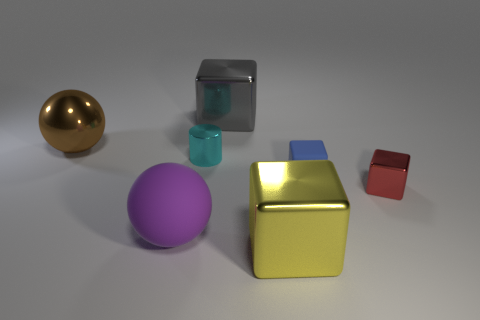Is the tiny blue cube that is right of the yellow cube made of the same material as the cube in front of the large purple rubber object?
Keep it short and to the point. No. There is a tiny thing right of the blue matte thing; what material is it?
Ensure brevity in your answer.  Metal. What number of metallic things are small blue objects or gray blocks?
Your response must be concise. 1. There is a thing that is behind the sphere behind the small red metal thing; what is its color?
Your answer should be very brief. Gray. Is the large brown sphere made of the same material as the large block that is to the right of the big gray metallic cube?
Offer a terse response. Yes. What is the color of the thing that is on the left side of the matte object left of the large thing that is in front of the purple rubber thing?
Make the answer very short. Brown. Is there any other thing that has the same shape as the tiny red thing?
Your answer should be compact. Yes. Are there more tiny red metallic blocks than big brown shiny cylinders?
Your response must be concise. Yes. What number of objects are in front of the red metal thing and on the right side of the large gray metallic block?
Offer a very short reply. 1. There is a tiny metal object to the left of the red metallic block; how many large spheres are left of it?
Your response must be concise. 2. 